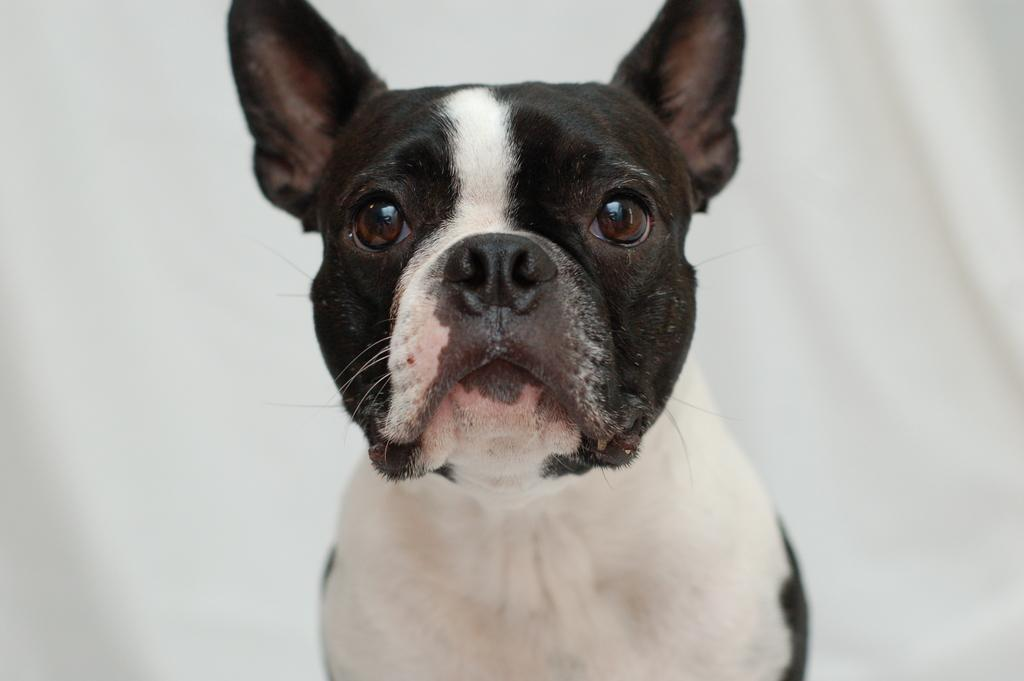What type of animal is in the image? There is a dog in the image. Can you describe the coloration of the dog? The dog has a white and black coloration. What color is the background of the image? The background of the image is white. How would you describe the quality of the image? The image is slightly blurry in the background. Where is the desk located in the image? There is no desk present in the image; it features a dog with a white and black coloration against a white background. What type of fairies can be seen playing in the background of the image? There are no fairies present in the image; it features a dog with a white and black coloration against a white background. 